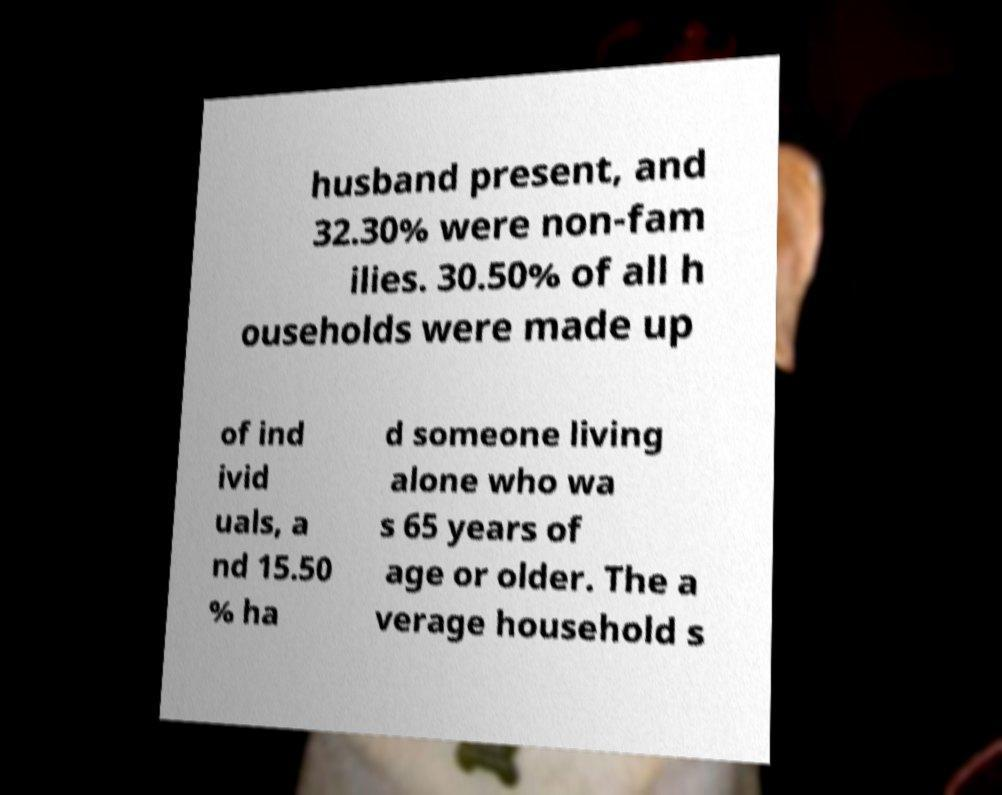Please read and relay the text visible in this image. What does it say? husband present, and 32.30% were non-fam ilies. 30.50% of all h ouseholds were made up of ind ivid uals, a nd 15.50 % ha d someone living alone who wa s 65 years of age or older. The a verage household s 